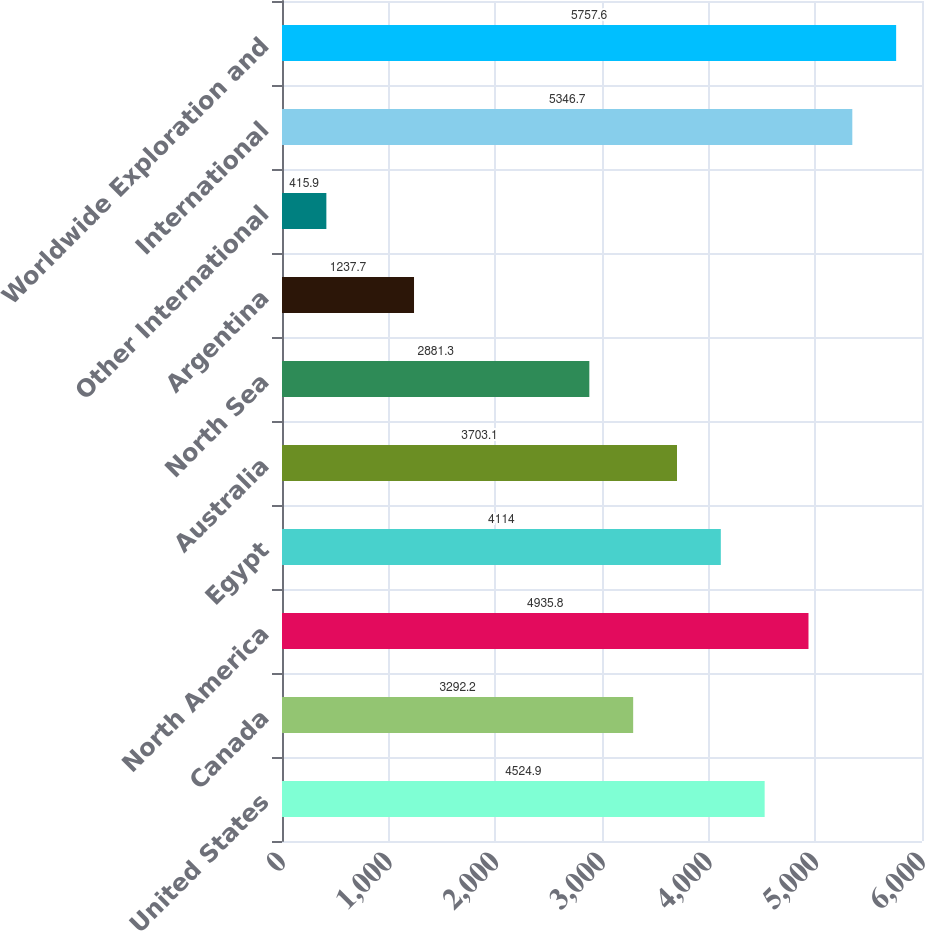<chart> <loc_0><loc_0><loc_500><loc_500><bar_chart><fcel>United States<fcel>Canada<fcel>North America<fcel>Egypt<fcel>Australia<fcel>North Sea<fcel>Argentina<fcel>Other International<fcel>International<fcel>Worldwide Exploration and<nl><fcel>4524.9<fcel>3292.2<fcel>4935.8<fcel>4114<fcel>3703.1<fcel>2881.3<fcel>1237.7<fcel>415.9<fcel>5346.7<fcel>5757.6<nl></chart> 